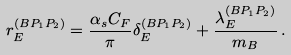<formula> <loc_0><loc_0><loc_500><loc_500>r ^ { ( B P _ { 1 } P _ { 2 } ) } _ { E } = \frac { \alpha _ { s } C _ { F } } { \pi } \delta ^ { ( B P _ { 1 } P _ { 2 } ) } _ { E } + \frac { \lambda _ { E } ^ { ( B P _ { 1 } P _ { 2 } ) } } { m _ { B } } \, .</formula> 